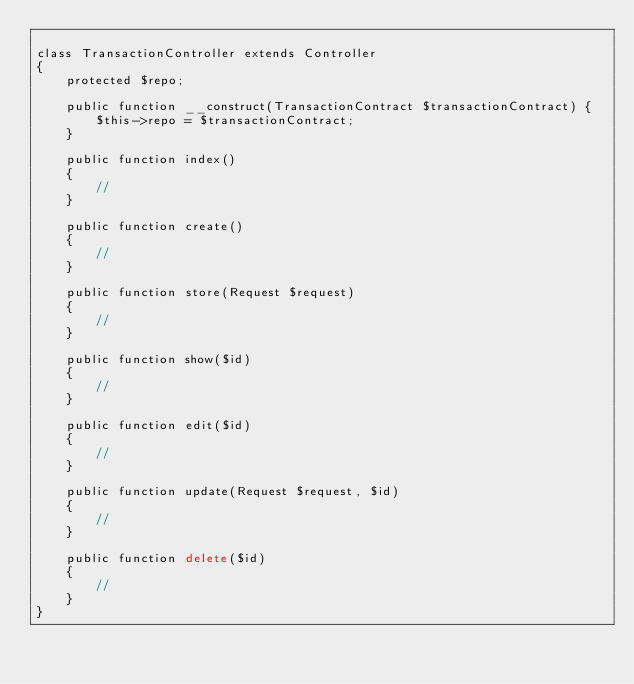<code> <loc_0><loc_0><loc_500><loc_500><_PHP_>
class TransactionController extends Controller
{
    protected $repo;

    public function __construct(TransactionContract $transactionContract) {
        $this->repo = $transactionContract;
    }
    
    public function index()
    {
        //
    }
    
    public function create()
    {
        //
    }
    
    public function store(Request $request)
    {
        //
    }
    
    public function show($id)
    {
        //
    }
    
    public function edit($id)
    {
        //
    }
    
    public function update(Request $request, $id)
    {
        //
    }
    
    public function delete($id)
    {
        //
    }
}
</code> 